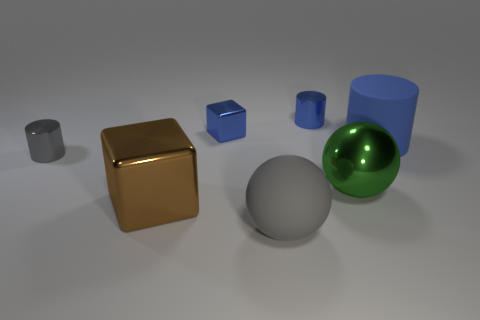Subtract all tiny cylinders. How many cylinders are left? 1 Add 2 small rubber things. How many objects exist? 9 Subtract all gray cylinders. How many cylinders are left? 2 Subtract 2 spheres. How many spheres are left? 0 Subtract all gray balls. Subtract all blue blocks. How many balls are left? 1 Subtract all purple blocks. How many blue cylinders are left? 2 Subtract all large gray rubber balls. Subtract all big blue rubber spheres. How many objects are left? 6 Add 5 big green objects. How many big green objects are left? 6 Add 7 metallic spheres. How many metallic spheres exist? 8 Subtract 1 brown blocks. How many objects are left? 6 